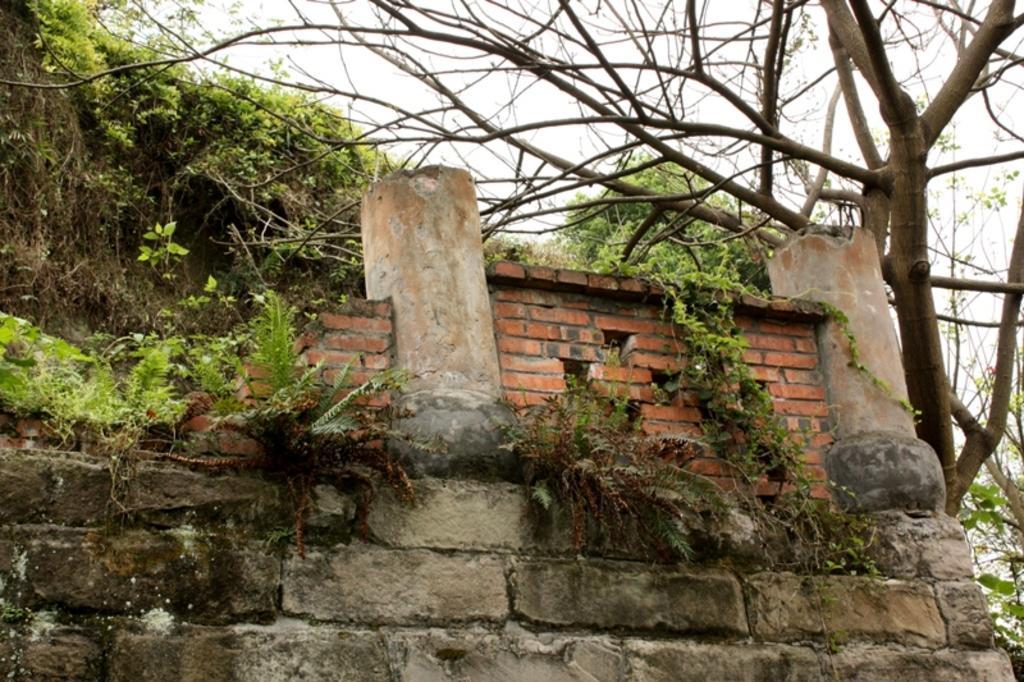Describe this image in one or two sentences. In the center of the image there is a wall, two pillars and a few other objects. In the background, we can see the sky, clouds, trees, plants etc. 